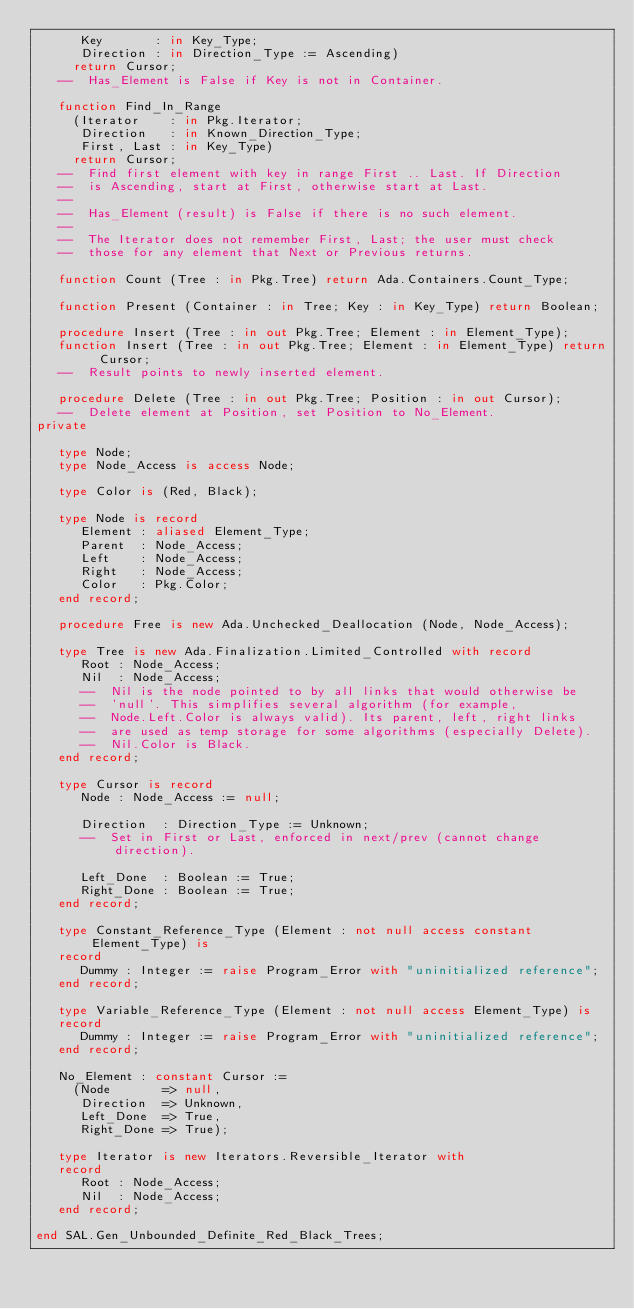<code> <loc_0><loc_0><loc_500><loc_500><_Ada_>      Key       : in Key_Type;
      Direction : in Direction_Type := Ascending)
     return Cursor;
   --  Has_Element is False if Key is not in Container.

   function Find_In_Range
     (Iterator    : in Pkg.Iterator;
      Direction   : in Known_Direction_Type;
      First, Last : in Key_Type)
     return Cursor;
   --  Find first element with key in range First .. Last. If Direction
   --  is Ascending, start at First, otherwise start at Last.
   --
   --  Has_Element (result) is False if there is no such element.
   --
   --  The Iterator does not remember First, Last; the user must check
   --  those for any element that Next or Previous returns.

   function Count (Tree : in Pkg.Tree) return Ada.Containers.Count_Type;

   function Present (Container : in Tree; Key : in Key_Type) return Boolean;

   procedure Insert (Tree : in out Pkg.Tree; Element : in Element_Type);
   function Insert (Tree : in out Pkg.Tree; Element : in Element_Type) return Cursor;
   --  Result points to newly inserted element.

   procedure Delete (Tree : in out Pkg.Tree; Position : in out Cursor);
   --  Delete element at Position, set Position to No_Element.
private

   type Node;
   type Node_Access is access Node;

   type Color is (Red, Black);

   type Node is record
      Element : aliased Element_Type;
      Parent  : Node_Access;
      Left    : Node_Access;
      Right   : Node_Access;
      Color   : Pkg.Color;
   end record;

   procedure Free is new Ada.Unchecked_Deallocation (Node, Node_Access);

   type Tree is new Ada.Finalization.Limited_Controlled with record
      Root : Node_Access;
      Nil  : Node_Access;
      --  Nil is the node pointed to by all links that would otherwise be
      --  'null'. This simplifies several algorithm (for example,
      --  Node.Left.Color is always valid). Its parent, left, right links
      --  are used as temp storage for some algorithms (especially Delete).
      --  Nil.Color is Black.
   end record;

   type Cursor is record
      Node : Node_Access := null;

      Direction  : Direction_Type := Unknown;
      --  Set in First or Last, enforced in next/prev (cannot change direction).

      Left_Done  : Boolean := True;
      Right_Done : Boolean := True;
   end record;

   type Constant_Reference_Type (Element : not null access constant Element_Type) is
   record
      Dummy : Integer := raise Program_Error with "uninitialized reference";
   end record;

   type Variable_Reference_Type (Element : not null access Element_Type) is
   record
      Dummy : Integer := raise Program_Error with "uninitialized reference";
   end record;

   No_Element : constant Cursor :=
     (Node       => null,
      Direction  => Unknown,
      Left_Done  => True,
      Right_Done => True);

   type Iterator is new Iterators.Reversible_Iterator with
   record
      Root : Node_Access;
      Nil  : Node_Access;
   end record;

end SAL.Gen_Unbounded_Definite_Red_Black_Trees;
</code> 